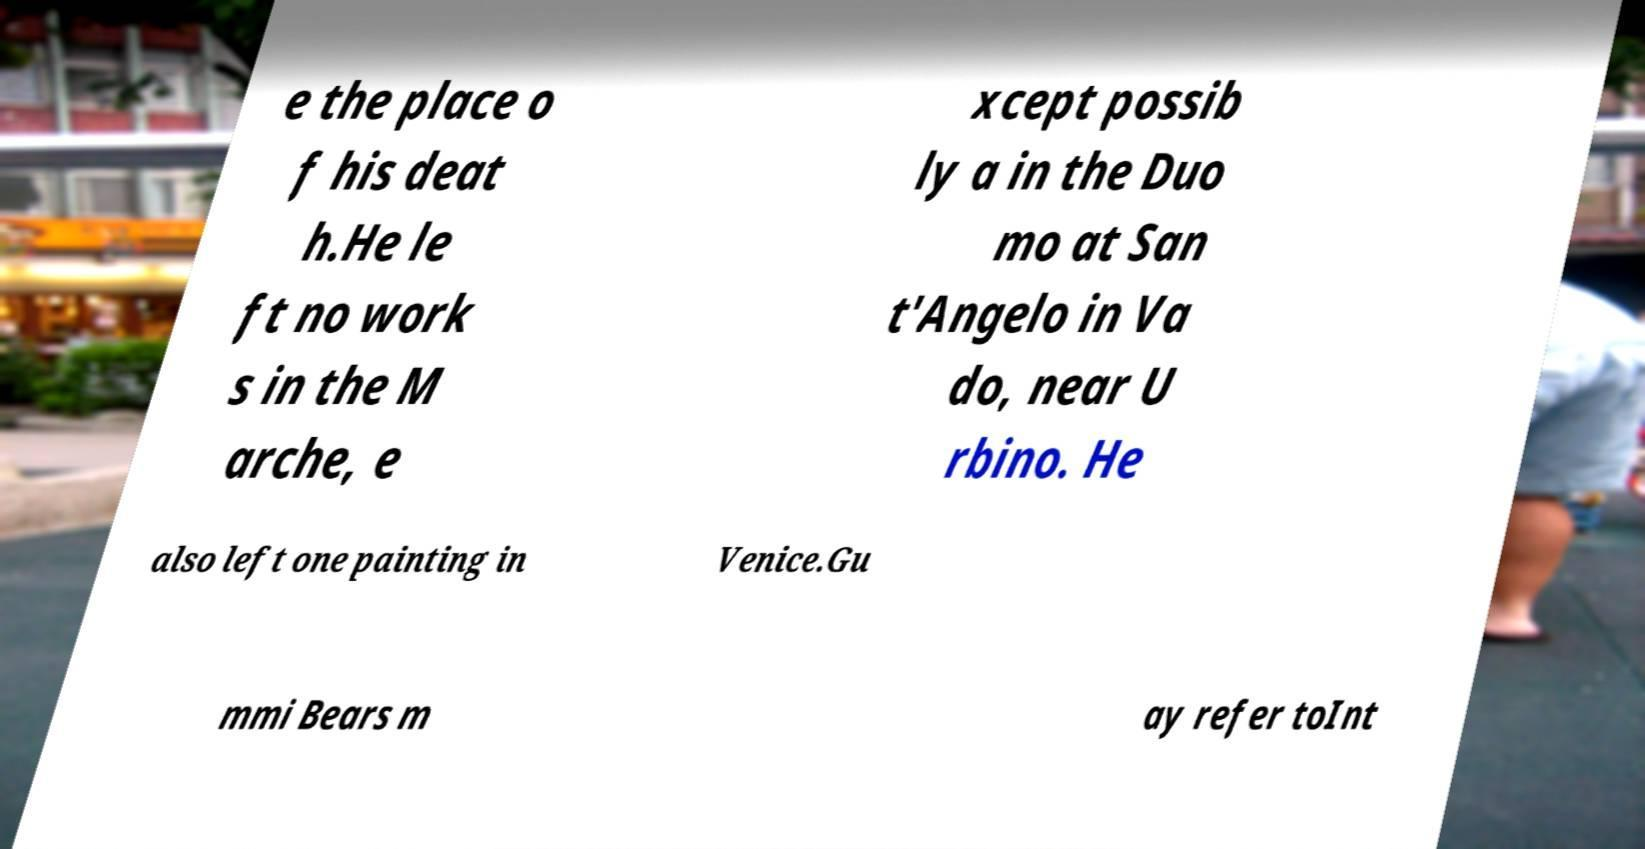I need the written content from this picture converted into text. Can you do that? e the place o f his deat h.He le ft no work s in the M arche, e xcept possib ly a in the Duo mo at San t'Angelo in Va do, near U rbino. He also left one painting in Venice.Gu mmi Bears m ay refer toInt 